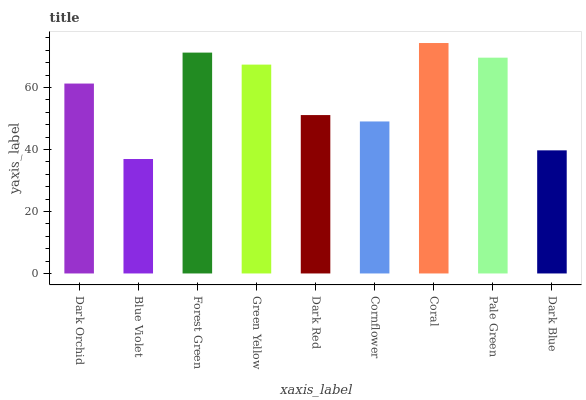Is Blue Violet the minimum?
Answer yes or no. Yes. Is Coral the maximum?
Answer yes or no. Yes. Is Forest Green the minimum?
Answer yes or no. No. Is Forest Green the maximum?
Answer yes or no. No. Is Forest Green greater than Blue Violet?
Answer yes or no. Yes. Is Blue Violet less than Forest Green?
Answer yes or no. Yes. Is Blue Violet greater than Forest Green?
Answer yes or no. No. Is Forest Green less than Blue Violet?
Answer yes or no. No. Is Dark Orchid the high median?
Answer yes or no. Yes. Is Dark Orchid the low median?
Answer yes or no. Yes. Is Forest Green the high median?
Answer yes or no. No. Is Green Yellow the low median?
Answer yes or no. No. 